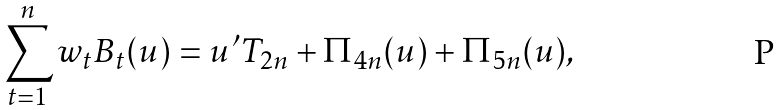Convert formula to latex. <formula><loc_0><loc_0><loc_500><loc_500>\sum _ { t = 1 } ^ { n } w _ { t } B _ { t } ( u ) = u ^ { \prime } T _ { 2 n } + \Pi _ { 4 n } ( u ) + \Pi _ { 5 n } ( u ) ,</formula> 